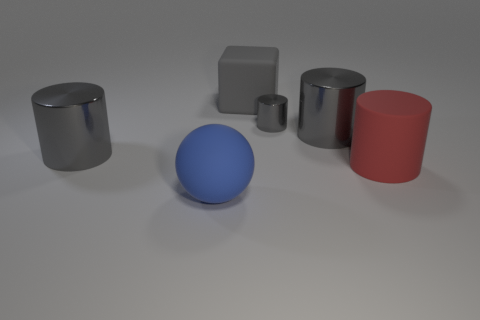What number of red cylinders are to the right of the big rubber object that is in front of the big red rubber cylinder that is on the right side of the big blue rubber sphere? Upon careful observation, there appears to be only one red cylinder positioned to the right of the grey cuboid, which itself is situated in front of the large red rubber cylinder to the right of the blue sphere. So the correct number of red cylinders fitting the description is indeed 1. 